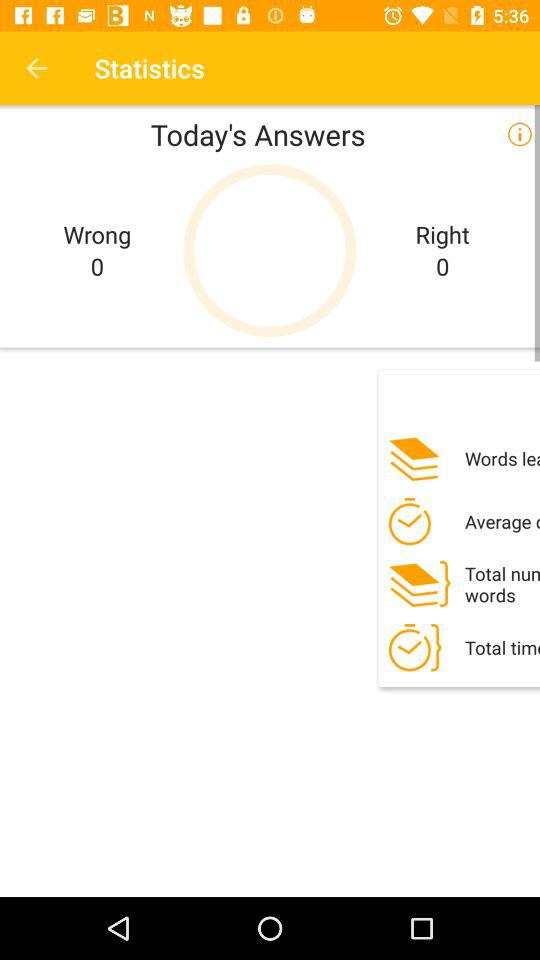How many right answers are there? There are 0 right answers. 